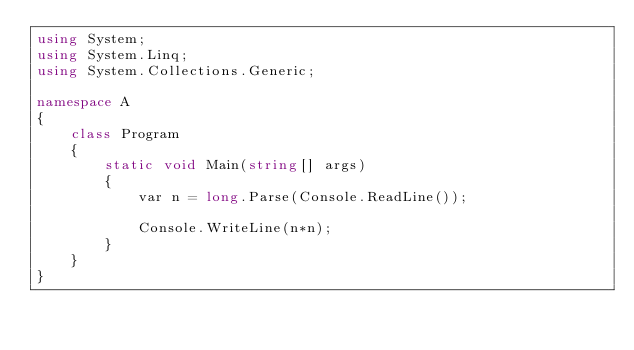<code> <loc_0><loc_0><loc_500><loc_500><_C#_>using System;
using System.Linq;
using System.Collections.Generic;

namespace A
{
    class Program
    {
        static void Main(string[] args)
        {
            var n = long.Parse(Console.ReadLine());

            Console.WriteLine(n*n);
        }
    }
}
</code> 